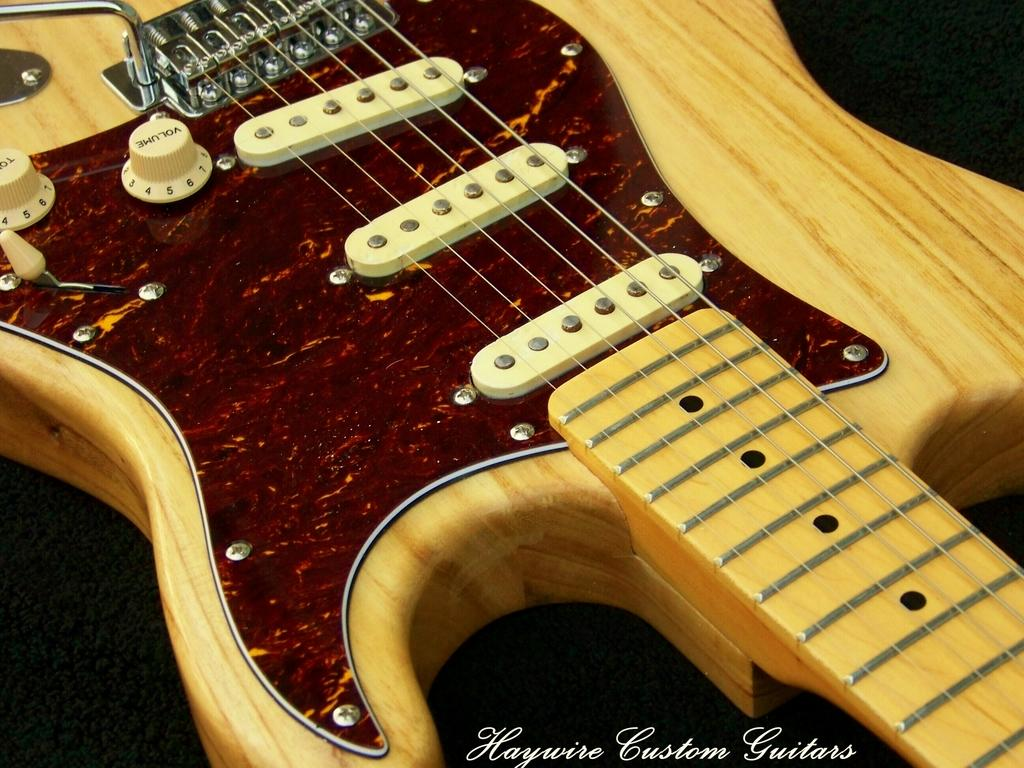What musical instrument is present in the image? There is a guitar in the image. Where is the guitar placed? The guitar is on an object. Is there any additional information about the image itself? Yes, there is a watermark on the image. How many ducks are visible in the image? There are no ducks present in the image. What type of shoe is shown near the guitar? There is no shoe present in the image. 